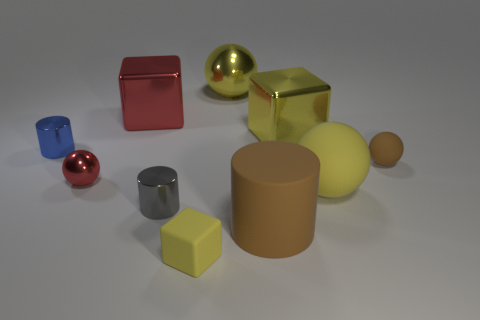Can you describe the different materials present in the various objects shown? Certainly! The objects display a variety of materials. The spheres and cubes exhibit shiny, reflective surfaces, indicative of metallic properties. The cylinders have more of a matte finish, suggesting a less reflective, perhaps plastic-like material. The varying textures and light reflections emphasize the diversity of materials represented in this collection. 